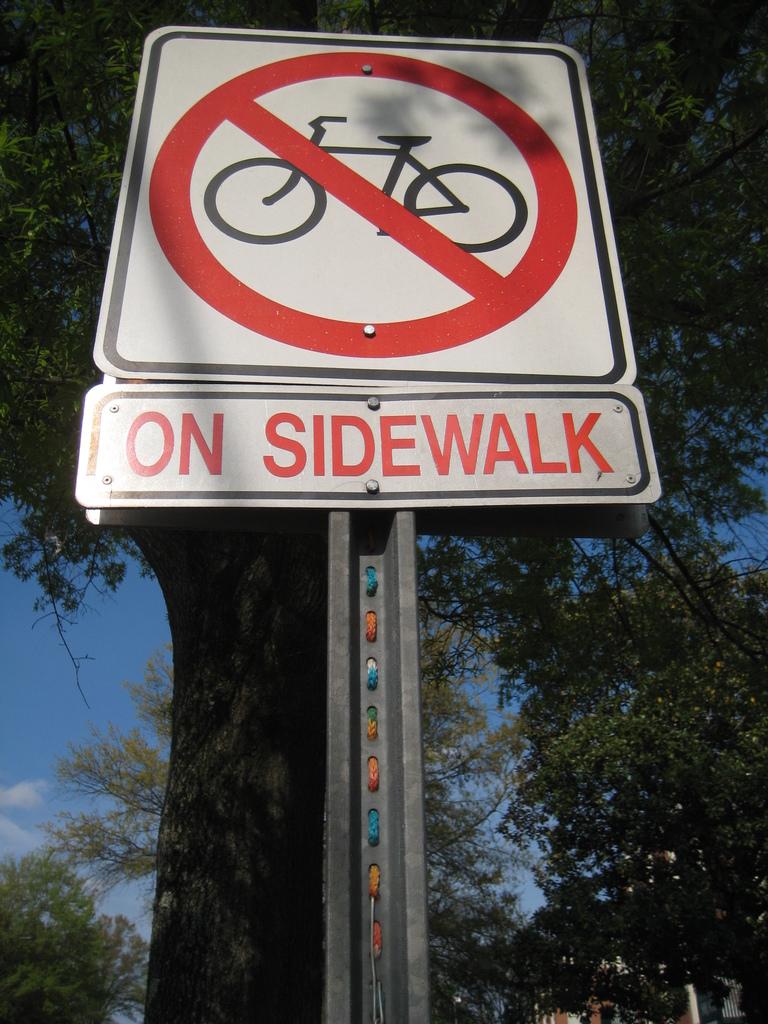Where are bikes not allowed?
Provide a short and direct response. On sidewalk. Where is this sign placed?
Your response must be concise. On sidewalk. 